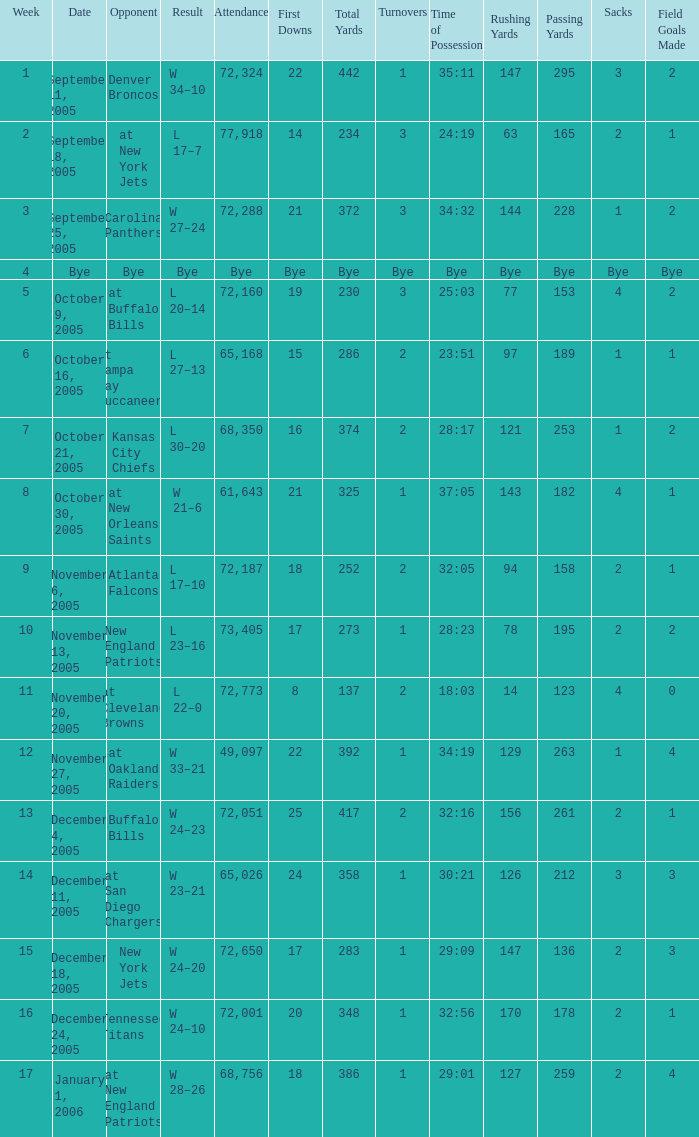In what Week was the Attendance 49,097? 12.0. 